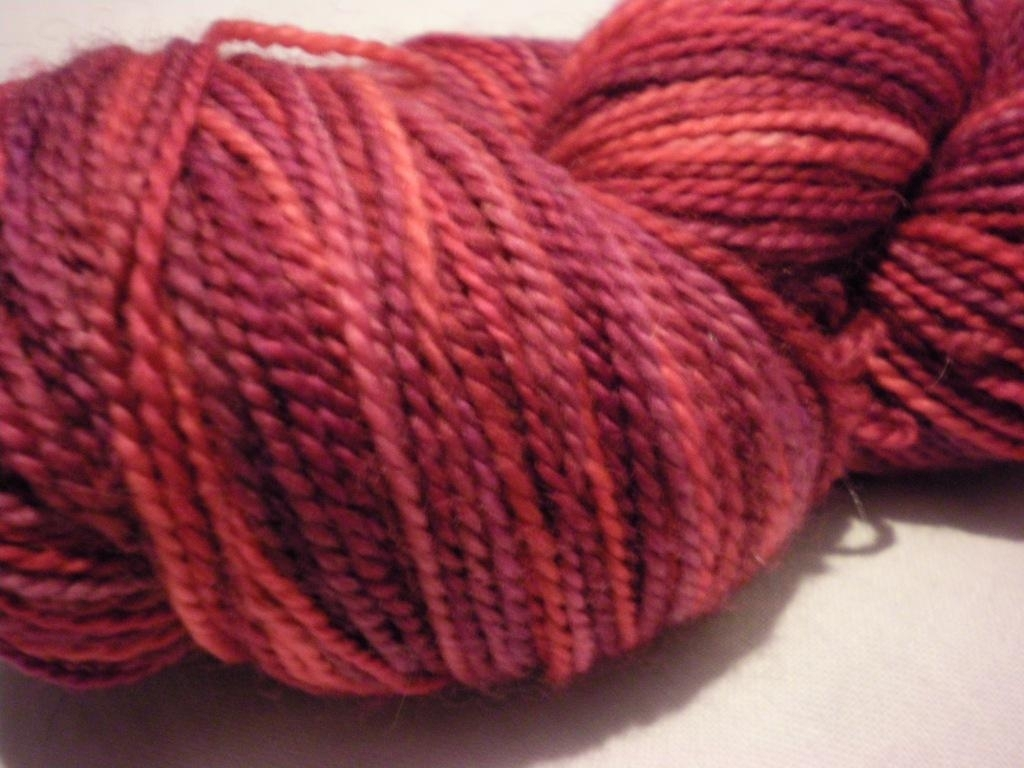Is the focusing of the image accurate? Upon closer examination, the image appears slightly out of focus, particularly when observing the texture of the yarn. The strands lack sharpness, indicating that the camera's focus might have been set slightly off the optimal point or there might have been some movement during the capture. For a more precise evaluation, checking the camera settings or attempting another shot with a steady hand or a tripod could be beneficial. 